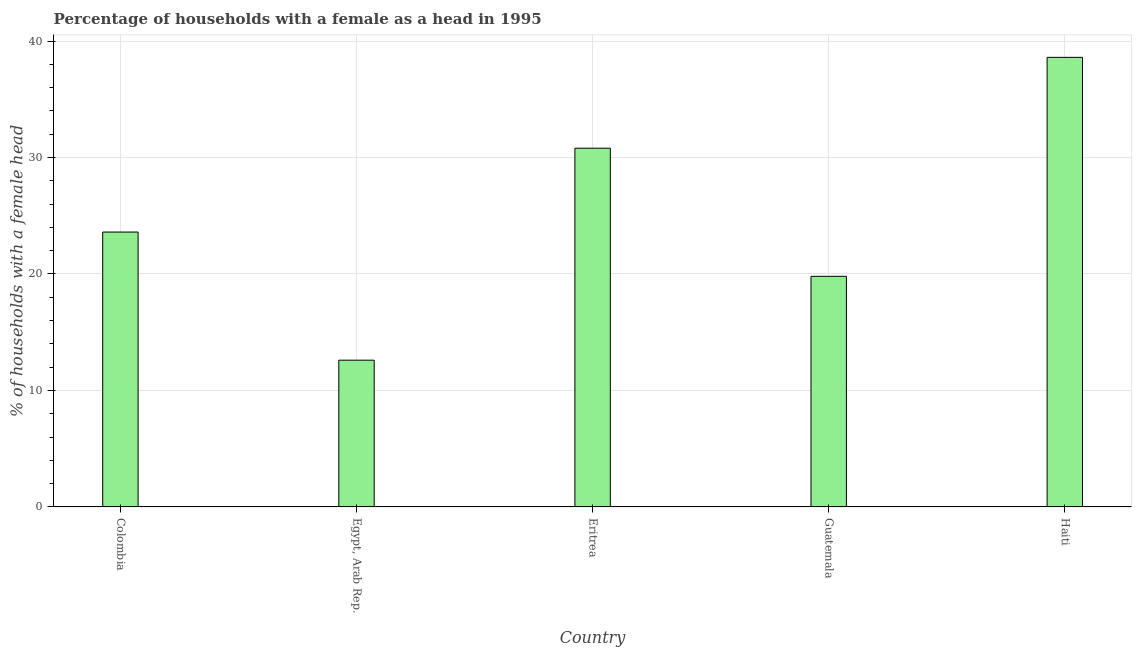Does the graph contain grids?
Keep it short and to the point. Yes. What is the title of the graph?
Ensure brevity in your answer.  Percentage of households with a female as a head in 1995. What is the label or title of the X-axis?
Offer a very short reply. Country. What is the label or title of the Y-axis?
Your answer should be very brief. % of households with a female head. What is the number of female supervised households in Egypt, Arab Rep.?
Your response must be concise. 12.6. Across all countries, what is the maximum number of female supervised households?
Provide a short and direct response. 38.6. In which country was the number of female supervised households maximum?
Ensure brevity in your answer.  Haiti. In which country was the number of female supervised households minimum?
Provide a succinct answer. Egypt, Arab Rep. What is the sum of the number of female supervised households?
Provide a succinct answer. 125.4. What is the average number of female supervised households per country?
Your answer should be compact. 25.08. What is the median number of female supervised households?
Offer a terse response. 23.6. What is the ratio of the number of female supervised households in Eritrea to that in Guatemala?
Offer a terse response. 1.56. Is the number of female supervised households in Colombia less than that in Guatemala?
Offer a terse response. No. Is the sum of the number of female supervised households in Egypt, Arab Rep. and Guatemala greater than the maximum number of female supervised households across all countries?
Your response must be concise. No. How many bars are there?
Your response must be concise. 5. Are the values on the major ticks of Y-axis written in scientific E-notation?
Make the answer very short. No. What is the % of households with a female head of Colombia?
Ensure brevity in your answer.  23.6. What is the % of households with a female head in Egypt, Arab Rep.?
Provide a short and direct response. 12.6. What is the % of households with a female head of Eritrea?
Offer a very short reply. 30.8. What is the % of households with a female head of Guatemala?
Your response must be concise. 19.8. What is the % of households with a female head of Haiti?
Keep it short and to the point. 38.6. What is the difference between the % of households with a female head in Colombia and Eritrea?
Ensure brevity in your answer.  -7.2. What is the difference between the % of households with a female head in Colombia and Guatemala?
Your answer should be compact. 3.8. What is the difference between the % of households with a female head in Colombia and Haiti?
Provide a succinct answer. -15. What is the difference between the % of households with a female head in Egypt, Arab Rep. and Eritrea?
Your answer should be very brief. -18.2. What is the difference between the % of households with a female head in Egypt, Arab Rep. and Guatemala?
Offer a very short reply. -7.2. What is the difference between the % of households with a female head in Egypt, Arab Rep. and Haiti?
Offer a terse response. -26. What is the difference between the % of households with a female head in Eritrea and Haiti?
Offer a terse response. -7.8. What is the difference between the % of households with a female head in Guatemala and Haiti?
Make the answer very short. -18.8. What is the ratio of the % of households with a female head in Colombia to that in Egypt, Arab Rep.?
Offer a very short reply. 1.87. What is the ratio of the % of households with a female head in Colombia to that in Eritrea?
Provide a succinct answer. 0.77. What is the ratio of the % of households with a female head in Colombia to that in Guatemala?
Keep it short and to the point. 1.19. What is the ratio of the % of households with a female head in Colombia to that in Haiti?
Your answer should be very brief. 0.61. What is the ratio of the % of households with a female head in Egypt, Arab Rep. to that in Eritrea?
Provide a short and direct response. 0.41. What is the ratio of the % of households with a female head in Egypt, Arab Rep. to that in Guatemala?
Your response must be concise. 0.64. What is the ratio of the % of households with a female head in Egypt, Arab Rep. to that in Haiti?
Your answer should be compact. 0.33. What is the ratio of the % of households with a female head in Eritrea to that in Guatemala?
Your answer should be compact. 1.56. What is the ratio of the % of households with a female head in Eritrea to that in Haiti?
Offer a terse response. 0.8. What is the ratio of the % of households with a female head in Guatemala to that in Haiti?
Your response must be concise. 0.51. 